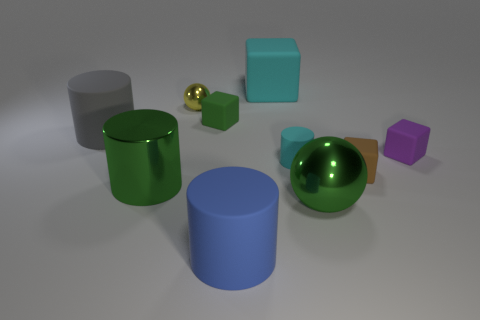Subtract all cyan cylinders. How many cylinders are left? 3 Subtract all blocks. How many objects are left? 6 Subtract 1 balls. How many balls are left? 1 Subtract all red blocks. Subtract all cyan cylinders. How many blocks are left? 4 Subtract all blue cylinders. How many blue blocks are left? 0 Subtract all rubber blocks. Subtract all big gray rubber objects. How many objects are left? 5 Add 4 large green metallic balls. How many large green metallic balls are left? 5 Add 3 tiny cyan matte cylinders. How many tiny cyan matte cylinders exist? 4 Subtract all big metal cylinders. How many cylinders are left? 3 Subtract 1 blue cylinders. How many objects are left? 9 